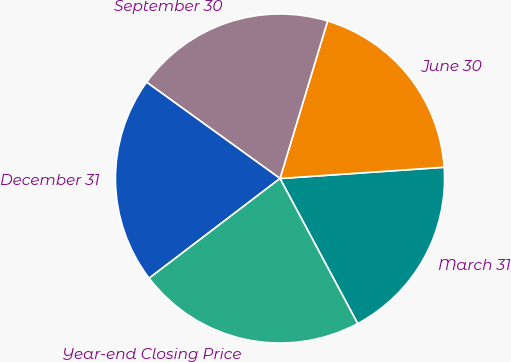Convert chart. <chart><loc_0><loc_0><loc_500><loc_500><pie_chart><fcel>March 31<fcel>June 30<fcel>September 30<fcel>December 31<fcel>Year-end Closing Price<nl><fcel>18.27%<fcel>19.24%<fcel>19.72%<fcel>20.31%<fcel>22.46%<nl></chart> 